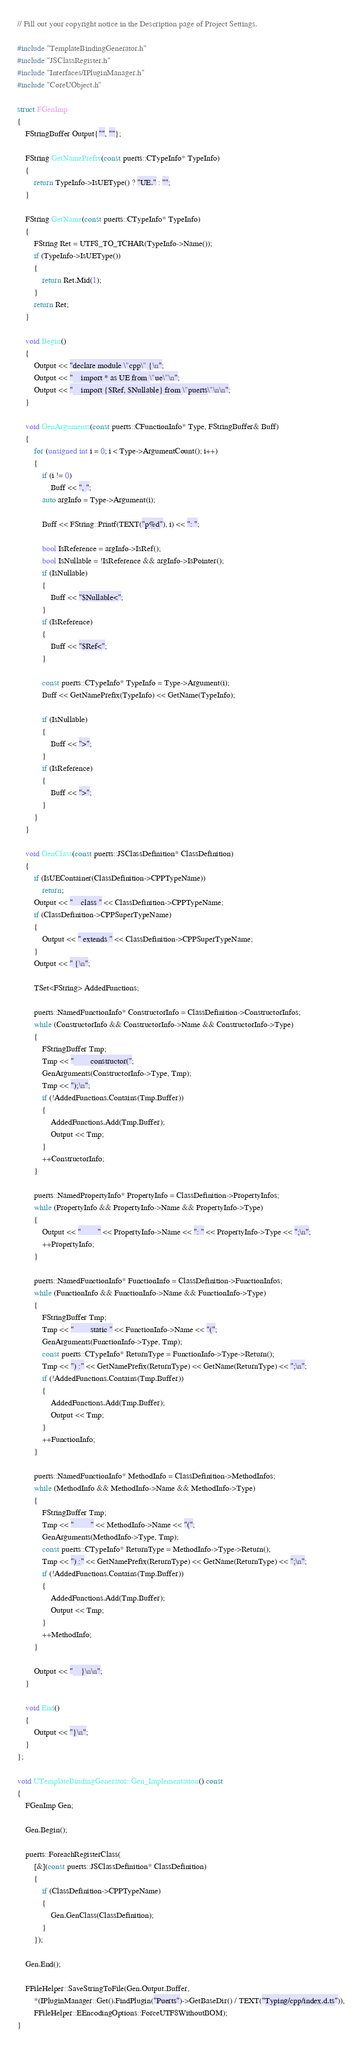Convert code to text. <code><loc_0><loc_0><loc_500><loc_500><_C++_>// Fill out your copyright notice in the Description page of Project Settings.

#include "TemplateBindingGenerator.h"
#include "JSClassRegister.h"
#include "Interfaces/IPluginManager.h"
#include "CoreUObject.h"

struct FGenImp
{
    FStringBuffer Output{"", ""};

    FString GetNamePrefix(const puerts::CTypeInfo* TypeInfo)
    {
        return TypeInfo->IsUEType() ? "UE." : "";
    }

    FString GetName(const puerts::CTypeInfo* TypeInfo)
    {
        FString Ret = UTF8_TO_TCHAR(TypeInfo->Name());
        if (TypeInfo->IsUEType())
        {
            return Ret.Mid(1);
        }
        return Ret;
    }

    void Begin()
    {
        Output << "declare module \"cpp\" {\n";
        Output << "    import * as UE from \"ue\"\n";
        Output << "    import {$Ref, $Nullable} from \"puerts\"\n\n";
    }

    void GenArguments(const puerts::CFunctionInfo* Type, FStringBuffer& Buff)
    {
        for (unsigned int i = 0; i < Type->ArgumentCount(); i++)
        {
            if (i != 0)
                Buff << ", ";
            auto argInfo = Type->Argument(i);

            Buff << FString::Printf(TEXT("p%d"), i) << ": ";

            bool IsReference = argInfo->IsRef();
            bool IsNullable = !IsReference && argInfo->IsPointer();
            if (IsNullable)
            {
                Buff << "$Nullable<";
            }
            if (IsReference)
            {
                Buff << "$Ref<";
            }

            const puerts::CTypeInfo* TypeInfo = Type->Argument(i);
            Buff << GetNamePrefix(TypeInfo) << GetName(TypeInfo);

            if (IsNullable)
            {
                Buff << ">";
            }
            if (IsReference)
            {
                Buff << ">";
            }
        }
    }

    void GenClass(const puerts::JSClassDefinition* ClassDefinition)
    {
        if (IsUEContainer(ClassDefinition->CPPTypeName))
            return;
        Output << "    class " << ClassDefinition->CPPTypeName;
        if (ClassDefinition->CPPSuperTypeName)
        {
            Output << " extends " << ClassDefinition->CPPSuperTypeName;
        }
        Output << " {\n";

        TSet<FString> AddedFunctions;

        puerts::NamedFunctionInfo* ConstructorInfo = ClassDefinition->ConstructorInfos;
        while (ConstructorInfo && ConstructorInfo->Name && ConstructorInfo->Type)
        {
            FStringBuffer Tmp;
            Tmp << "        constructor(";
            GenArguments(ConstructorInfo->Type, Tmp);
            Tmp << ");\n";
            if (!AddedFunctions.Contains(Tmp.Buffer))
            {
                AddedFunctions.Add(Tmp.Buffer);
                Output << Tmp;
            }
            ++ConstructorInfo;
        }

        puerts::NamedPropertyInfo* PropertyInfo = ClassDefinition->PropertyInfos;
        while (PropertyInfo && PropertyInfo->Name && PropertyInfo->Type)
        {
            Output << "        " << PropertyInfo->Name << ": " << PropertyInfo->Type << ";\n";
            ++PropertyInfo;
        }

        puerts::NamedFunctionInfo* FunctionInfo = ClassDefinition->FunctionInfos;
        while (FunctionInfo && FunctionInfo->Name && FunctionInfo->Type)
        {
            FStringBuffer Tmp;
            Tmp << "        static " << FunctionInfo->Name << "(";
            GenArguments(FunctionInfo->Type, Tmp);
            const puerts::CTypeInfo* ReturnType = FunctionInfo->Type->Return();
            Tmp << ") :" << GetNamePrefix(ReturnType) << GetName(ReturnType) << ";\n";
            if (!AddedFunctions.Contains(Tmp.Buffer))
            {
                AddedFunctions.Add(Tmp.Buffer);
                Output << Tmp;
            }
            ++FunctionInfo;
        }

        puerts::NamedFunctionInfo* MethodInfo = ClassDefinition->MethodInfos;
        while (MethodInfo && MethodInfo->Name && MethodInfo->Type)
        {
            FStringBuffer Tmp;
            Tmp << "        " << MethodInfo->Name << "(";
            GenArguments(MethodInfo->Type, Tmp);
            const puerts::CTypeInfo* ReturnType = MethodInfo->Type->Return();
            Tmp << ") :" << GetNamePrefix(ReturnType) << GetName(ReturnType) << ";\n";
            if (!AddedFunctions.Contains(Tmp.Buffer))
            {
                AddedFunctions.Add(Tmp.Buffer);
                Output << Tmp;
            }
            ++MethodInfo;
        }

        Output << "    }\n\n";
    }

    void End()
    {
        Output << "}\n";
    }
};

void UTemplateBindingGenerator::Gen_Implementation() const
{
    FGenImp Gen;

    Gen.Begin();

    puerts::ForeachRegisterClass(
        [&](const puerts::JSClassDefinition* ClassDefinition)
        {
            if (ClassDefinition->CPPTypeName)
            {
                Gen.GenClass(ClassDefinition);
            }
        });

    Gen.End();

    FFileHelper::SaveStringToFile(Gen.Output.Buffer,
        *(IPluginManager::Get().FindPlugin("Puerts")->GetBaseDir() / TEXT("Typing/cpp/index.d.ts")),
        FFileHelper::EEncodingOptions::ForceUTF8WithoutBOM);
}
</code> 